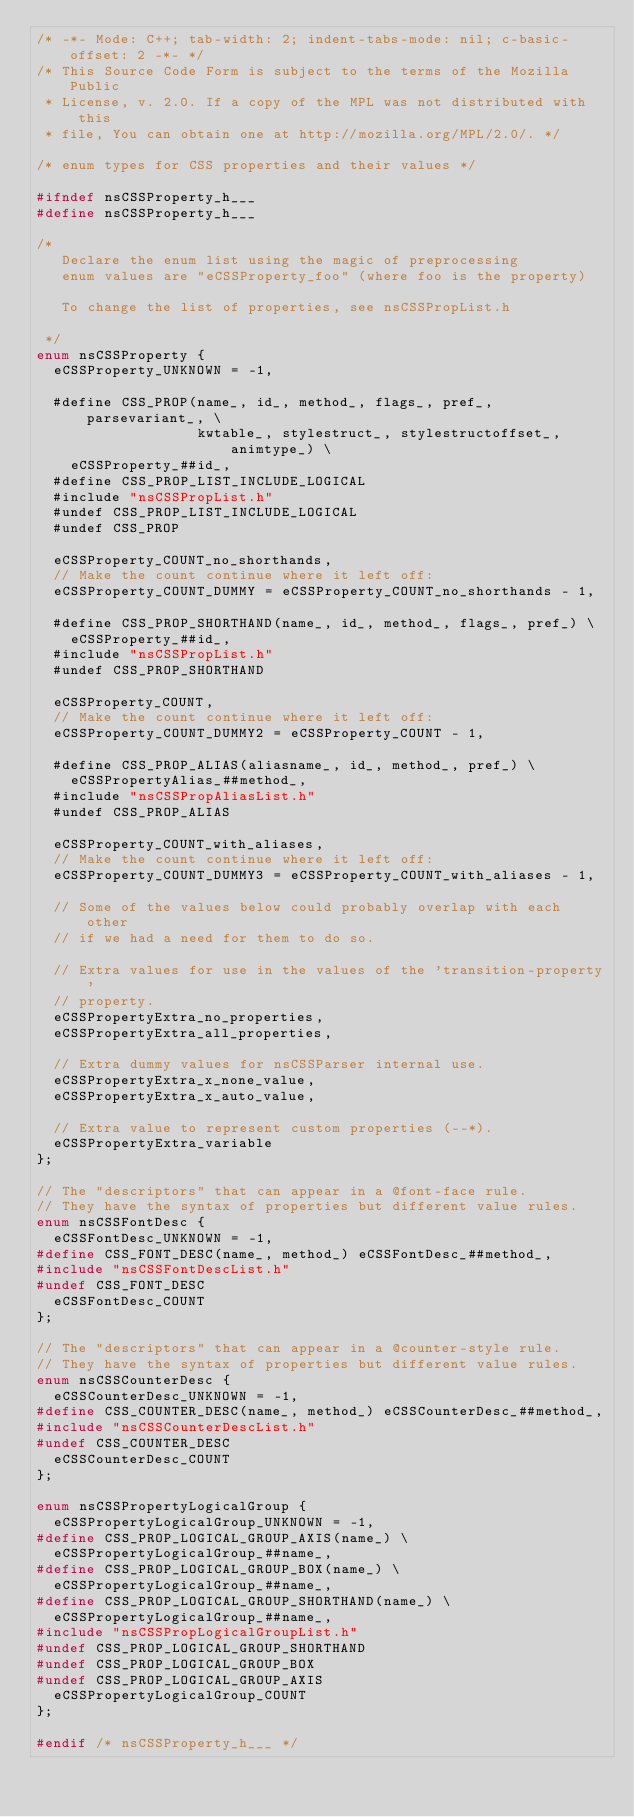<code> <loc_0><loc_0><loc_500><loc_500><_C_>/* -*- Mode: C++; tab-width: 2; indent-tabs-mode: nil; c-basic-offset: 2 -*- */
/* This Source Code Form is subject to the terms of the Mozilla Public
 * License, v. 2.0. If a copy of the MPL was not distributed with this
 * file, You can obtain one at http://mozilla.org/MPL/2.0/. */

/* enum types for CSS properties and their values */
 
#ifndef nsCSSProperty_h___
#define nsCSSProperty_h___

/*
   Declare the enum list using the magic of preprocessing
   enum values are "eCSSProperty_foo" (where foo is the property)

   To change the list of properties, see nsCSSPropList.h

 */
enum nsCSSProperty {
  eCSSProperty_UNKNOWN = -1,

  #define CSS_PROP(name_, id_, method_, flags_, pref_, parsevariant_, \
                   kwtable_, stylestruct_, stylestructoffset_, animtype_) \
    eCSSProperty_##id_,
  #define CSS_PROP_LIST_INCLUDE_LOGICAL
  #include "nsCSSPropList.h"
  #undef CSS_PROP_LIST_INCLUDE_LOGICAL
  #undef CSS_PROP

  eCSSProperty_COUNT_no_shorthands,
  // Make the count continue where it left off:
  eCSSProperty_COUNT_DUMMY = eCSSProperty_COUNT_no_shorthands - 1,

  #define CSS_PROP_SHORTHAND(name_, id_, method_, flags_, pref_) \
    eCSSProperty_##id_,
  #include "nsCSSPropList.h"
  #undef CSS_PROP_SHORTHAND

  eCSSProperty_COUNT,
  // Make the count continue where it left off:
  eCSSProperty_COUNT_DUMMY2 = eCSSProperty_COUNT - 1,

  #define CSS_PROP_ALIAS(aliasname_, id_, method_, pref_) \
    eCSSPropertyAlias_##method_,
  #include "nsCSSPropAliasList.h"
  #undef CSS_PROP_ALIAS

  eCSSProperty_COUNT_with_aliases,
  // Make the count continue where it left off:
  eCSSProperty_COUNT_DUMMY3 = eCSSProperty_COUNT_with_aliases - 1,

  // Some of the values below could probably overlap with each other
  // if we had a need for them to do so.

  // Extra values for use in the values of the 'transition-property'
  // property.
  eCSSPropertyExtra_no_properties,
  eCSSPropertyExtra_all_properties,

  // Extra dummy values for nsCSSParser internal use.
  eCSSPropertyExtra_x_none_value,
  eCSSPropertyExtra_x_auto_value,

  // Extra value to represent custom properties (--*).
  eCSSPropertyExtra_variable
};

// The "descriptors" that can appear in a @font-face rule.
// They have the syntax of properties but different value rules.
enum nsCSSFontDesc {
  eCSSFontDesc_UNKNOWN = -1,
#define CSS_FONT_DESC(name_, method_) eCSSFontDesc_##method_,
#include "nsCSSFontDescList.h"
#undef CSS_FONT_DESC
  eCSSFontDesc_COUNT
};

// The "descriptors" that can appear in a @counter-style rule.
// They have the syntax of properties but different value rules.
enum nsCSSCounterDesc {
  eCSSCounterDesc_UNKNOWN = -1,
#define CSS_COUNTER_DESC(name_, method_) eCSSCounterDesc_##method_,
#include "nsCSSCounterDescList.h"
#undef CSS_COUNTER_DESC
  eCSSCounterDesc_COUNT
};

enum nsCSSPropertyLogicalGroup {
  eCSSPropertyLogicalGroup_UNKNOWN = -1,
#define CSS_PROP_LOGICAL_GROUP_AXIS(name_) \
  eCSSPropertyLogicalGroup_##name_,
#define CSS_PROP_LOGICAL_GROUP_BOX(name_) \
  eCSSPropertyLogicalGroup_##name_,
#define CSS_PROP_LOGICAL_GROUP_SHORTHAND(name_) \
  eCSSPropertyLogicalGroup_##name_,
#include "nsCSSPropLogicalGroupList.h"
#undef CSS_PROP_LOGICAL_GROUP_SHORTHAND
#undef CSS_PROP_LOGICAL_GROUP_BOX
#undef CSS_PROP_LOGICAL_GROUP_AXIS
  eCSSPropertyLogicalGroup_COUNT
};

#endif /* nsCSSProperty_h___ */
</code> 